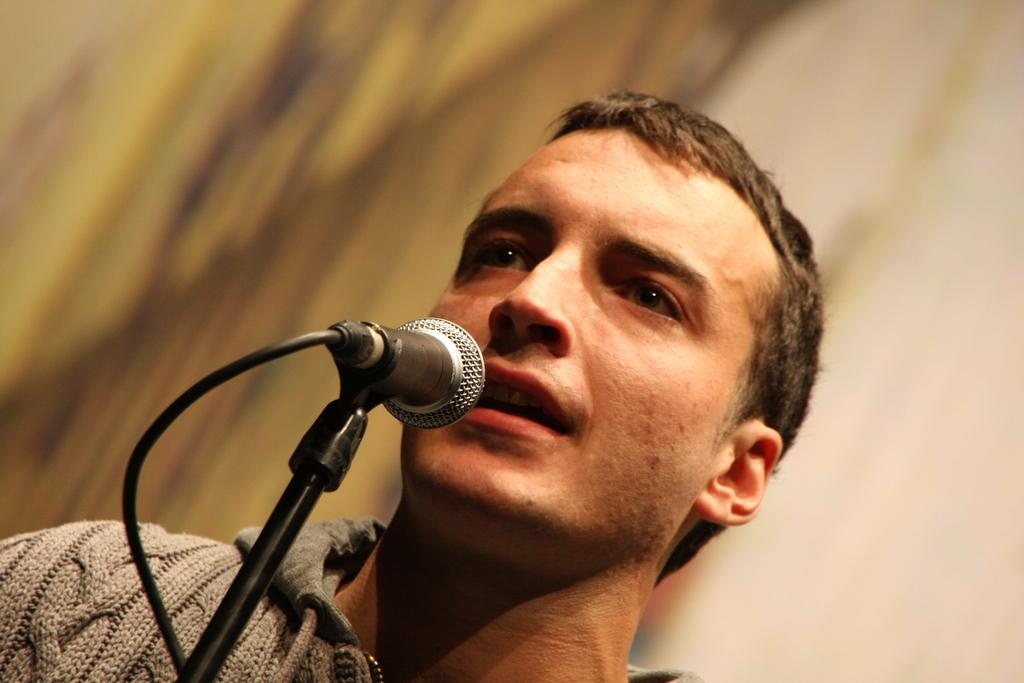Who is the main subject in the image? There is a man in the image. What is the man wearing? The man is wearing a brown sweater. What is the man doing in the image? The man is singing. What object is the man holding? The man is holding a microphone. Can you describe the background of the image? The background of the image is blurred. What type of ground is visible beneath the man in the image? There is no ground visible beneath the man in the image, as it appears to be a close-up shot focused on the man and his actions. 